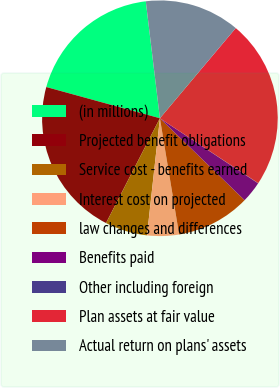Convert chart to OTSL. <chart><loc_0><loc_0><loc_500><loc_500><pie_chart><fcel>(in millions)<fcel>Projected benefit obligations<fcel>Service cost - benefits earned<fcel>Interest cost on projected<fcel>law changes and differences<fcel>Benefits paid<fcel>Other including foreign<fcel>Plan assets at fair value<fcel>Actual return on plans' assets<nl><fcel>18.82%<fcel>21.71%<fcel>5.81%<fcel>4.36%<fcel>10.15%<fcel>2.92%<fcel>0.03%<fcel>23.16%<fcel>13.04%<nl></chart> 